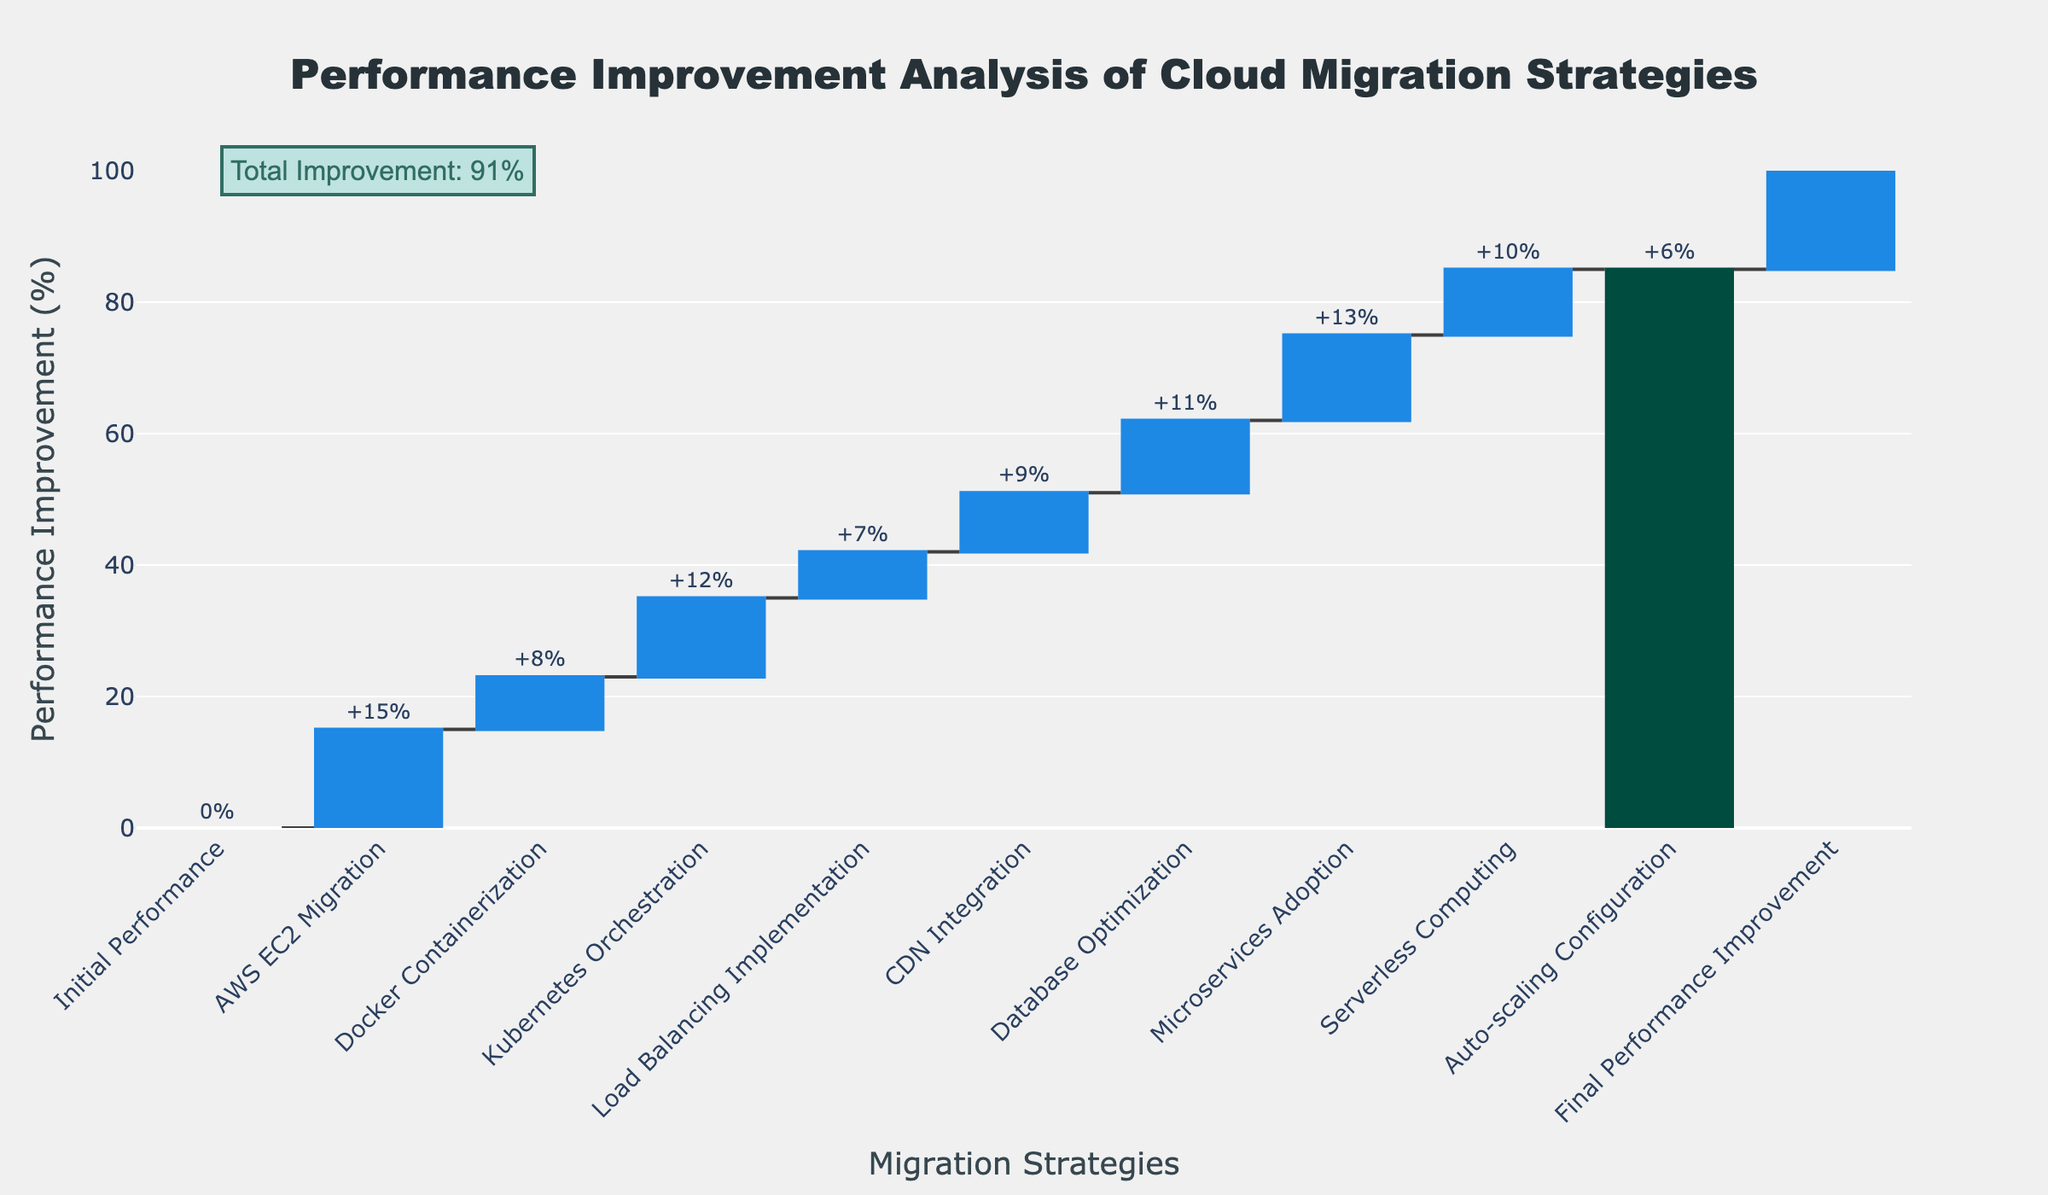What's the title of the chart? The title is usually displayed at the top of the chart and gives an overview of what the chart is about. In this case, you can see the title clearly stated.
Answer: Performance Improvement Analysis of Cloud Migration Strategies What's the total performance improvement after applying all migration strategies? The final total performance improvement is explicitly stated in the final bar and also annotated on the chart.
Answer: 91% How many migration strategies were applied before reaching the final performance improvement? Count the number of categories listed on the x-axis before the 'Final Performance Improvement' category. Each category represents a migration strategy.
Answer: 9 Which migration strategy contributed the most to performance improvement? Look for the bar with the highest positive value among the migration strategies.
Answer: AWS EC2 Migration What is the performance improvement contribution from Docker Containerization? The performance improvement contribution from Docker Containerization is written on the corresponding bar in the chart.
Answer: 8% What is the combined performance improvement of Load Balancing Implementation and CDN Integration? Add the performance improvements from Load Balancing Implementation and CDN Integration together: 7% + 9% = 16%.
Answer: 16% Which strategy has a higher impact on performance: Microservices Adoption or Serverless Computing? Compare the values corresponding to Microservices Adoption and Serverless Computing.
Answer: Microservices Adoption How much lower is the performance improvement from Auto-scaling Configuration compared to Database Optimization? Subtract the Auto-scaling Configuration improvement from Database Optimization improvement: 11% - 6% = 5%.
Answer: 5% What’s the average performance improvement per migration strategy (excluding the total)? Add the values of all migration strategies and divide by the number of strategies: (15 + 8 + 12 + 7 + 9 + 11 + 13 + 10 + 6) / 9 = 91 / 9 = 10.11%.
Answer: 10.11% What is the difference in performance improvement between Kubernetes Orchestration and Docker Containerization? Subtract the Docker Containerization improvement from Kubernetes Orchestration improvement: 12% - 8% = 4%.
Answer: 4% 